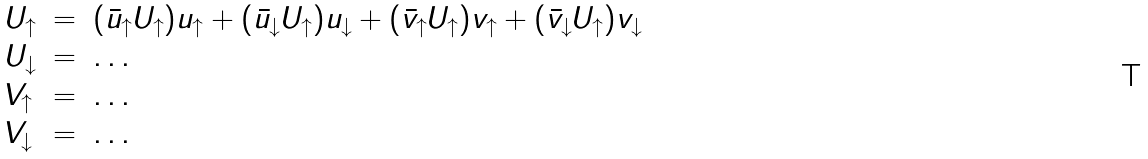Convert formula to latex. <formula><loc_0><loc_0><loc_500><loc_500>\begin{array} { l l l l } { { U _ { \uparrow } } } & { = } & { { ( { \bar { u } _ { \uparrow } } U _ { \uparrow } ) u _ { \uparrow } + ( { \bar { u } _ { \downarrow } } U _ { \uparrow } ) u _ { \downarrow } + ( { \bar { v } _ { \uparrow } } U _ { \uparrow } ) v _ { \uparrow } + ( { \bar { v } _ { \downarrow } } U _ { \uparrow } ) v _ { \downarrow } } } \\ { { U _ { \downarrow } } } & { = } & { \dots } \\ { { V _ { \uparrow } } } & { = } & { \dots } \\ { { V _ { \downarrow } } } & { = } & { \dots } \end{array}</formula> 